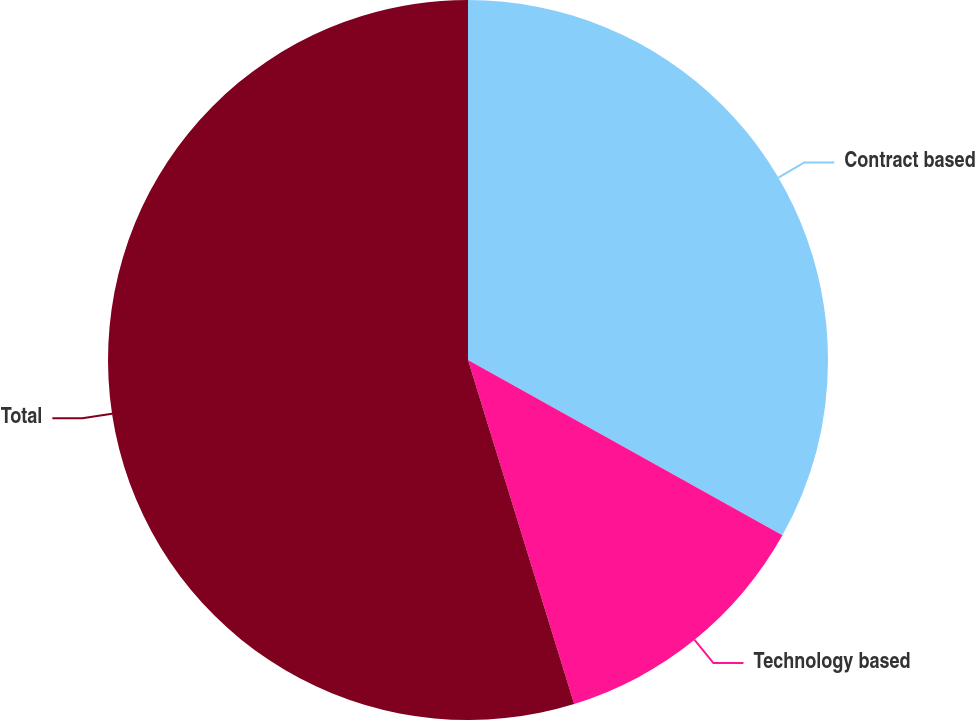Convert chart to OTSL. <chart><loc_0><loc_0><loc_500><loc_500><pie_chart><fcel>Contract based<fcel>Technology based<fcel>Total<nl><fcel>33.1%<fcel>12.14%<fcel>54.77%<nl></chart> 